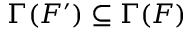<formula> <loc_0><loc_0><loc_500><loc_500>\Gamma ( F ^ { \prime } ) \subseteq \Gamma ( F )</formula> 